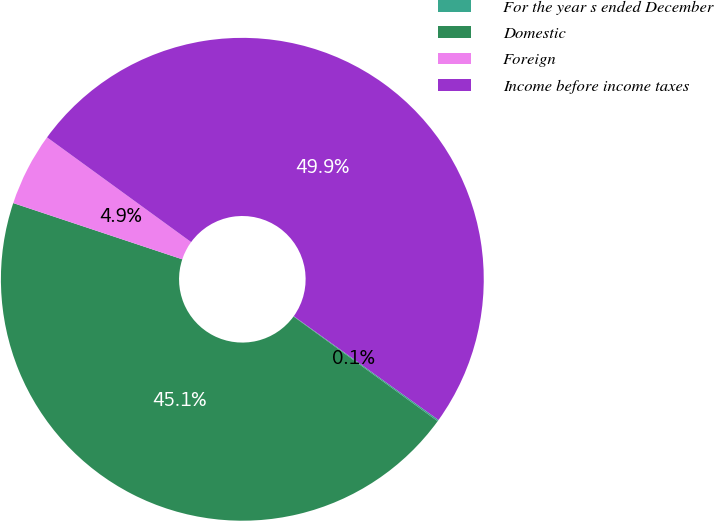<chart> <loc_0><loc_0><loc_500><loc_500><pie_chart><fcel>For the year s ended December<fcel>Domestic<fcel>Foreign<fcel>Income before income taxes<nl><fcel>0.1%<fcel>45.11%<fcel>4.89%<fcel>49.9%<nl></chart> 